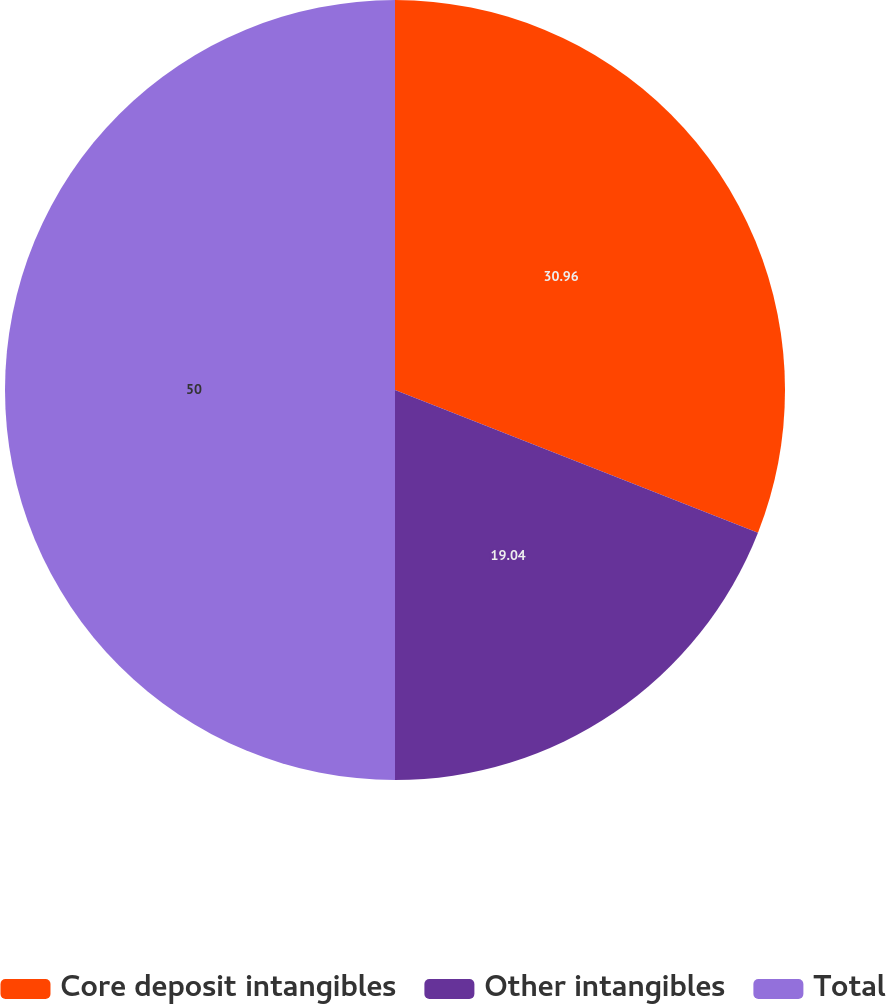Convert chart to OTSL. <chart><loc_0><loc_0><loc_500><loc_500><pie_chart><fcel>Core deposit intangibles<fcel>Other intangibles<fcel>Total<nl><fcel>30.96%<fcel>19.04%<fcel>50.0%<nl></chart> 